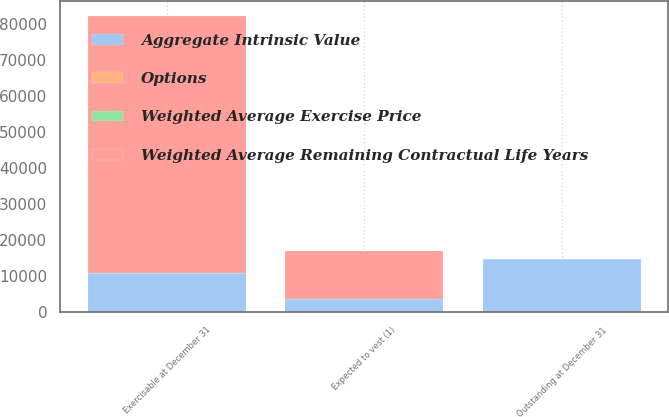Convert chart. <chart><loc_0><loc_0><loc_500><loc_500><stacked_bar_chart><ecel><fcel>Outstanding at December 31<fcel>Expected to vest (1)<fcel>Exercisable at December 31<nl><fcel>Aggregate Intrinsic Value<fcel>14874<fcel>3656<fcel>10985<nl><fcel>Options<fcel>7.5<fcel>9.59<fcel>6.75<nl><fcel>Weighted Average Exercise Price<fcel>3.6<fcel>7.1<fcel>2.4<nl><fcel>Weighted Average Remaining Contractual Life Years<fcel>9.59<fcel>13267<fcel>71114<nl></chart> 